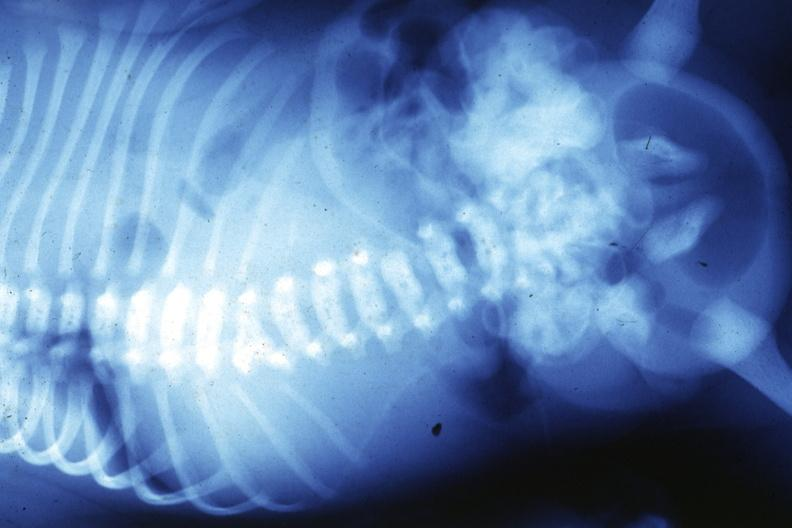s joints present?
Answer the question using a single word or phrase. Yes 